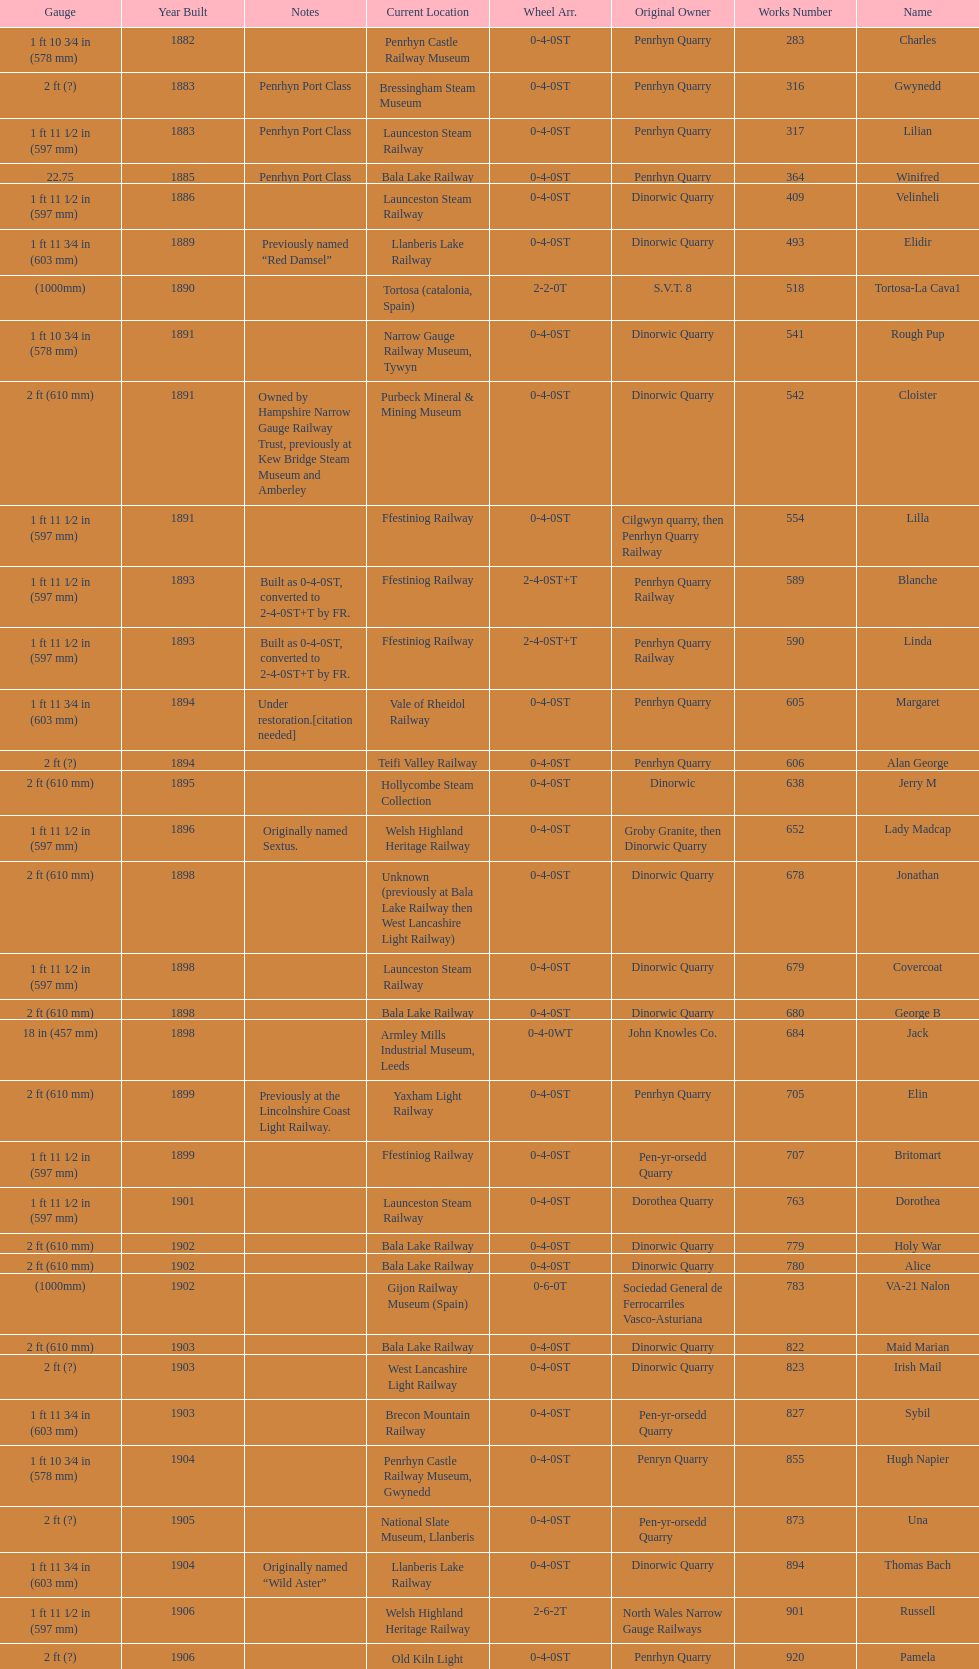Which original owner had the most locomotives? Penrhyn Quarry. 